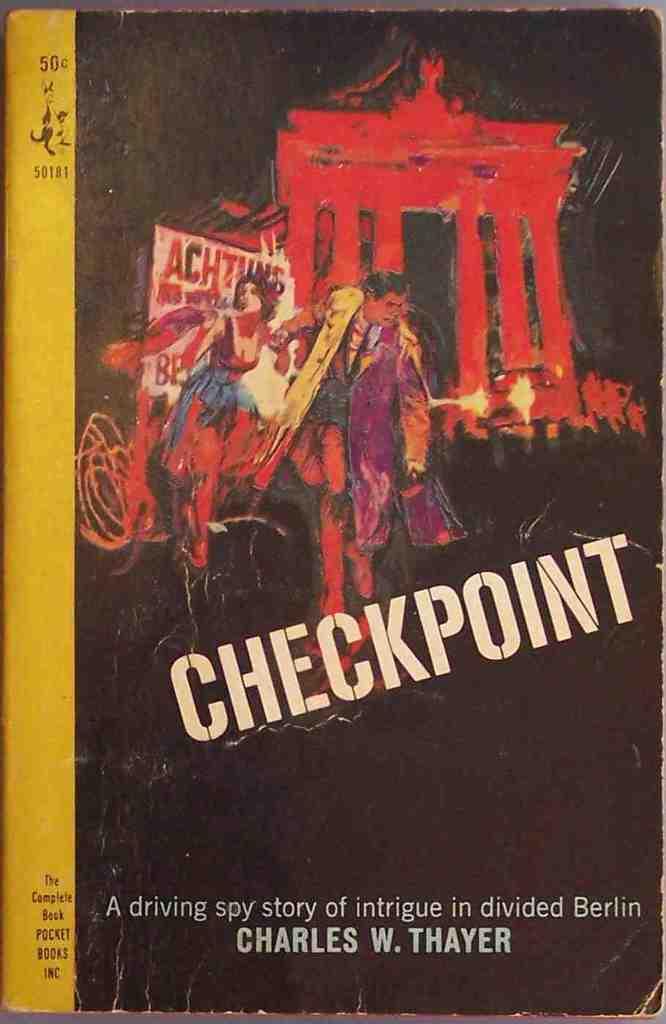What is the title of the book?
Provide a short and direct response. Checkpoint. What type of story is this?
Offer a very short reply. Checkpoint. 